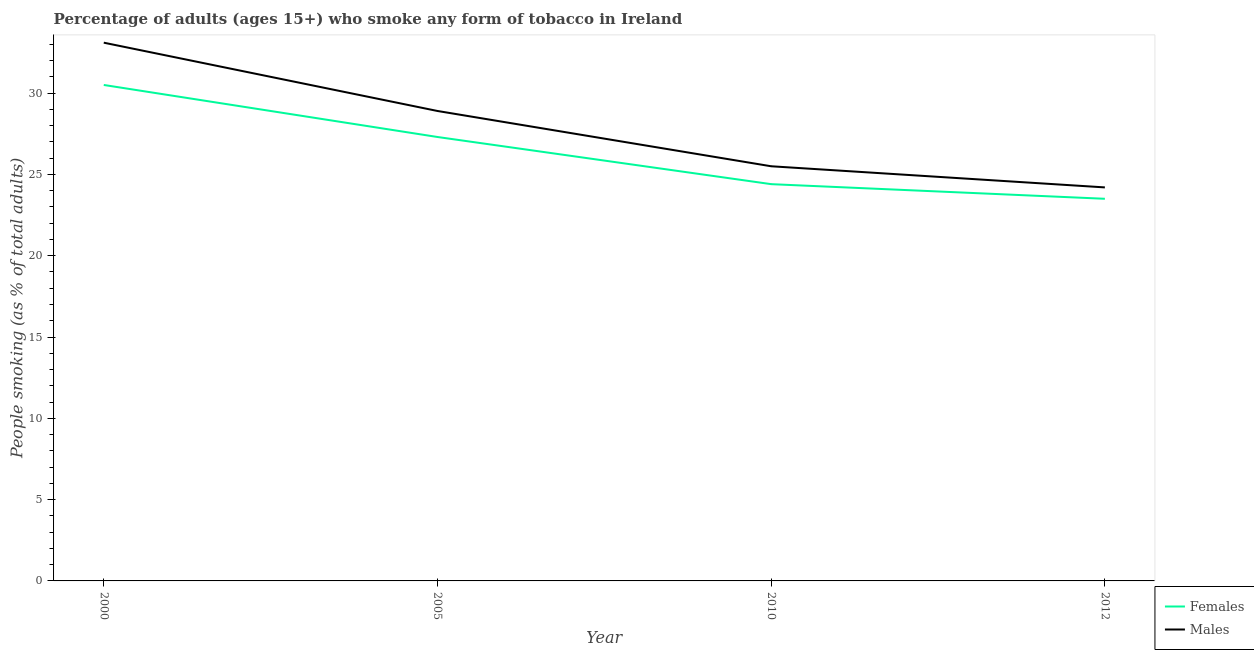How many different coloured lines are there?
Make the answer very short. 2. What is the percentage of males who smoke in 2005?
Your answer should be very brief. 28.9. Across all years, what is the maximum percentage of females who smoke?
Keep it short and to the point. 30.5. Across all years, what is the minimum percentage of females who smoke?
Ensure brevity in your answer.  23.5. What is the total percentage of males who smoke in the graph?
Keep it short and to the point. 111.7. What is the difference between the percentage of females who smoke in 2005 and that in 2010?
Make the answer very short. 2.9. What is the difference between the percentage of females who smoke in 2010 and the percentage of males who smoke in 2000?
Keep it short and to the point. -8.7. What is the average percentage of females who smoke per year?
Your answer should be compact. 26.42. In the year 2000, what is the difference between the percentage of males who smoke and percentage of females who smoke?
Give a very brief answer. 2.6. In how many years, is the percentage of males who smoke greater than 12 %?
Your answer should be compact. 4. What is the ratio of the percentage of females who smoke in 2000 to that in 2005?
Provide a short and direct response. 1.12. Is the percentage of females who smoke in 2000 less than that in 2012?
Offer a very short reply. No. What is the difference between the highest and the second highest percentage of females who smoke?
Make the answer very short. 3.2. What is the difference between the highest and the lowest percentage of males who smoke?
Make the answer very short. 8.9. Is the sum of the percentage of females who smoke in 2005 and 2010 greater than the maximum percentage of males who smoke across all years?
Make the answer very short. Yes. Are the values on the major ticks of Y-axis written in scientific E-notation?
Offer a terse response. No. Where does the legend appear in the graph?
Provide a succinct answer. Bottom right. How many legend labels are there?
Keep it short and to the point. 2. How are the legend labels stacked?
Provide a succinct answer. Vertical. What is the title of the graph?
Provide a succinct answer. Percentage of adults (ages 15+) who smoke any form of tobacco in Ireland. Does "Revenue" appear as one of the legend labels in the graph?
Your answer should be very brief. No. What is the label or title of the Y-axis?
Offer a terse response. People smoking (as % of total adults). What is the People smoking (as % of total adults) in Females in 2000?
Keep it short and to the point. 30.5. What is the People smoking (as % of total adults) in Males in 2000?
Ensure brevity in your answer.  33.1. What is the People smoking (as % of total adults) in Females in 2005?
Your answer should be compact. 27.3. What is the People smoking (as % of total adults) in Males in 2005?
Your response must be concise. 28.9. What is the People smoking (as % of total adults) in Females in 2010?
Give a very brief answer. 24.4. What is the People smoking (as % of total adults) of Males in 2010?
Your answer should be compact. 25.5. What is the People smoking (as % of total adults) of Males in 2012?
Your answer should be very brief. 24.2. Across all years, what is the maximum People smoking (as % of total adults) of Females?
Make the answer very short. 30.5. Across all years, what is the maximum People smoking (as % of total adults) of Males?
Your response must be concise. 33.1. Across all years, what is the minimum People smoking (as % of total adults) of Males?
Your response must be concise. 24.2. What is the total People smoking (as % of total adults) of Females in the graph?
Provide a short and direct response. 105.7. What is the total People smoking (as % of total adults) of Males in the graph?
Your answer should be compact. 111.7. What is the difference between the People smoking (as % of total adults) in Males in 2000 and that in 2005?
Provide a succinct answer. 4.2. What is the difference between the People smoking (as % of total adults) of Females in 2000 and that in 2010?
Your answer should be very brief. 6.1. What is the difference between the People smoking (as % of total adults) in Males in 2000 and that in 2010?
Give a very brief answer. 7.6. What is the difference between the People smoking (as % of total adults) of Males in 2000 and that in 2012?
Offer a very short reply. 8.9. What is the difference between the People smoking (as % of total adults) of Females in 2005 and that in 2010?
Offer a very short reply. 2.9. What is the difference between the People smoking (as % of total adults) of Males in 2005 and that in 2010?
Give a very brief answer. 3.4. What is the difference between the People smoking (as % of total adults) in Females in 2005 and that in 2012?
Provide a succinct answer. 3.8. What is the difference between the People smoking (as % of total adults) of Females in 2000 and the People smoking (as % of total adults) of Males in 2005?
Provide a succinct answer. 1.6. What is the difference between the People smoking (as % of total adults) in Females in 2000 and the People smoking (as % of total adults) in Males in 2010?
Provide a succinct answer. 5. What is the difference between the People smoking (as % of total adults) of Females in 2005 and the People smoking (as % of total adults) of Males in 2012?
Ensure brevity in your answer.  3.1. What is the difference between the People smoking (as % of total adults) of Females in 2010 and the People smoking (as % of total adults) of Males in 2012?
Ensure brevity in your answer.  0.2. What is the average People smoking (as % of total adults) in Females per year?
Ensure brevity in your answer.  26.43. What is the average People smoking (as % of total adults) of Males per year?
Make the answer very short. 27.93. In the year 2000, what is the difference between the People smoking (as % of total adults) in Females and People smoking (as % of total adults) in Males?
Your response must be concise. -2.6. In the year 2010, what is the difference between the People smoking (as % of total adults) of Females and People smoking (as % of total adults) of Males?
Your answer should be very brief. -1.1. In the year 2012, what is the difference between the People smoking (as % of total adults) in Females and People smoking (as % of total adults) in Males?
Ensure brevity in your answer.  -0.7. What is the ratio of the People smoking (as % of total adults) of Females in 2000 to that in 2005?
Give a very brief answer. 1.12. What is the ratio of the People smoking (as % of total adults) in Males in 2000 to that in 2005?
Provide a short and direct response. 1.15. What is the ratio of the People smoking (as % of total adults) of Females in 2000 to that in 2010?
Provide a short and direct response. 1.25. What is the ratio of the People smoking (as % of total adults) of Males in 2000 to that in 2010?
Give a very brief answer. 1.3. What is the ratio of the People smoking (as % of total adults) in Females in 2000 to that in 2012?
Provide a succinct answer. 1.3. What is the ratio of the People smoking (as % of total adults) in Males in 2000 to that in 2012?
Keep it short and to the point. 1.37. What is the ratio of the People smoking (as % of total adults) of Females in 2005 to that in 2010?
Make the answer very short. 1.12. What is the ratio of the People smoking (as % of total adults) of Males in 2005 to that in 2010?
Ensure brevity in your answer.  1.13. What is the ratio of the People smoking (as % of total adults) in Females in 2005 to that in 2012?
Your answer should be compact. 1.16. What is the ratio of the People smoking (as % of total adults) of Males in 2005 to that in 2012?
Offer a terse response. 1.19. What is the ratio of the People smoking (as % of total adults) in Females in 2010 to that in 2012?
Make the answer very short. 1.04. What is the ratio of the People smoking (as % of total adults) in Males in 2010 to that in 2012?
Provide a short and direct response. 1.05. What is the difference between the highest and the second highest People smoking (as % of total adults) of Females?
Offer a very short reply. 3.2. What is the difference between the highest and the second highest People smoking (as % of total adults) in Males?
Provide a succinct answer. 4.2. What is the difference between the highest and the lowest People smoking (as % of total adults) of Females?
Ensure brevity in your answer.  7. What is the difference between the highest and the lowest People smoking (as % of total adults) in Males?
Provide a short and direct response. 8.9. 